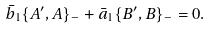<formula> <loc_0><loc_0><loc_500><loc_500>\bar { b } _ { 1 } \{ A ^ { \prime } , A \} _ { - } + \bar { a } _ { 1 } \{ B ^ { \prime } , B \} _ { - } = 0 .</formula> 